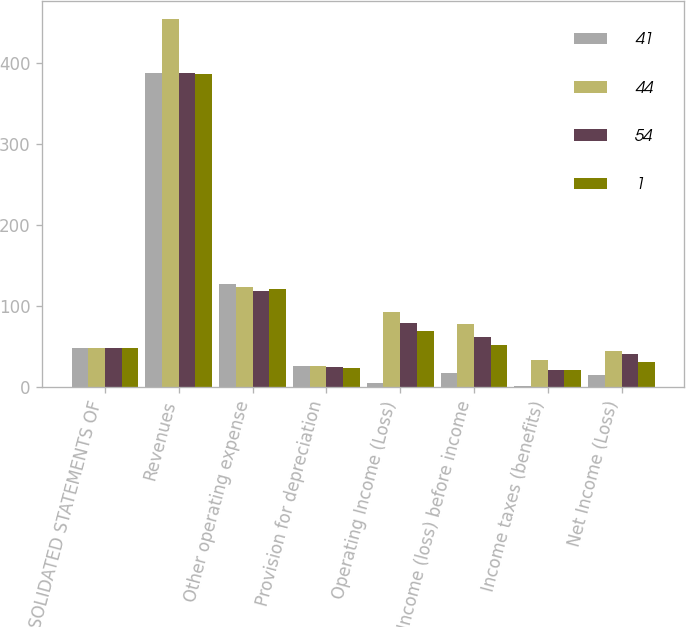Convert chart to OTSL. <chart><loc_0><loc_0><loc_500><loc_500><stacked_bar_chart><ecel><fcel>CONSOLIDATED STATEMENTS OF<fcel>Revenues<fcel>Other operating expense<fcel>Provision for depreciation<fcel>Operating Income (Loss)<fcel>Income (loss) before income<fcel>Income taxes (benefits)<fcel>Net Income (Loss)<nl><fcel>41<fcel>48<fcel>387<fcel>127<fcel>26<fcel>5<fcel>17<fcel>2<fcel>15<nl><fcel>44<fcel>48<fcel>454<fcel>124<fcel>26<fcel>93<fcel>78<fcel>34<fcel>44<nl><fcel>54<fcel>48<fcel>388<fcel>119<fcel>25<fcel>79<fcel>62<fcel>21<fcel>41<nl><fcel>1<fcel>48<fcel>386<fcel>121<fcel>24<fcel>69<fcel>52<fcel>21<fcel>31<nl></chart> 